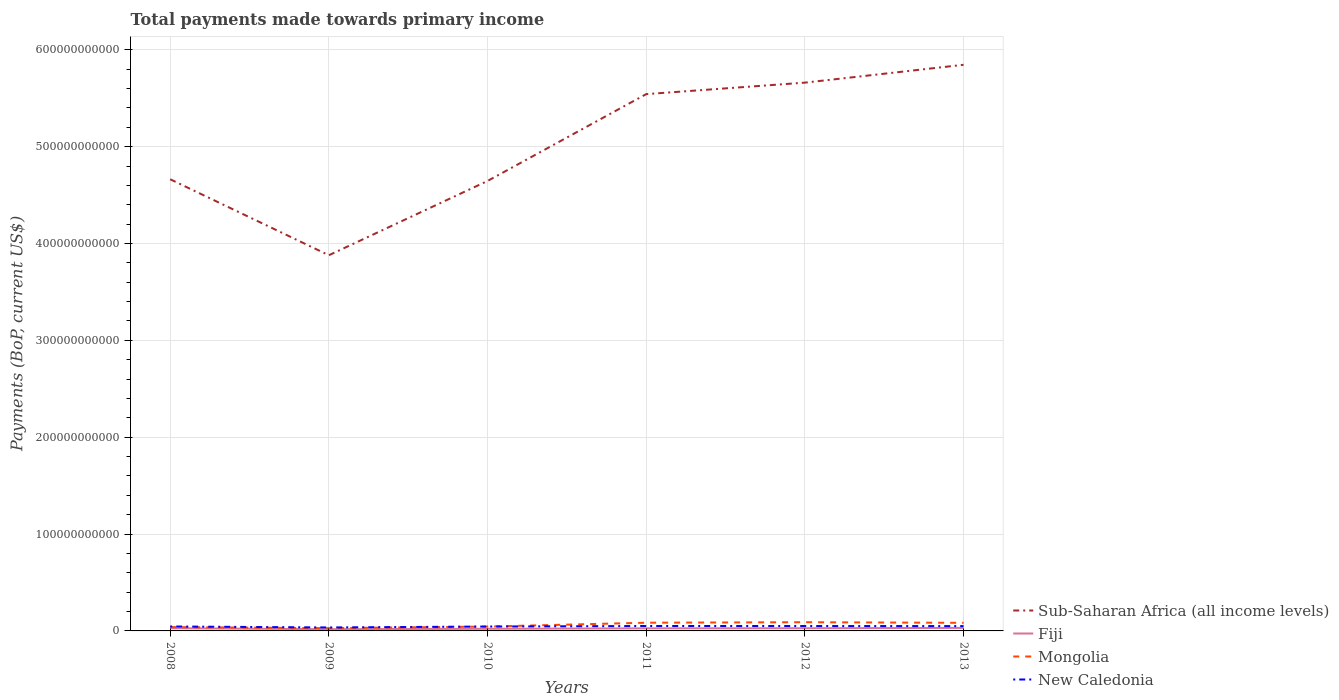How many different coloured lines are there?
Make the answer very short. 4. Does the line corresponding to Sub-Saharan Africa (all income levels) intersect with the line corresponding to Mongolia?
Give a very brief answer. No. Across all years, what is the maximum total payments made towards primary income in Sub-Saharan Africa (all income levels)?
Your response must be concise. 3.88e+11. What is the total total payments made towards primary income in Sub-Saharan Africa (all income levels) in the graph?
Keep it short and to the point. -3.03e+1. What is the difference between the highest and the second highest total payments made towards primary income in New Caledonia?
Offer a terse response. 1.51e+09. Is the total payments made towards primary income in Mongolia strictly greater than the total payments made towards primary income in Fiji over the years?
Your answer should be compact. No. How many years are there in the graph?
Make the answer very short. 6. What is the difference between two consecutive major ticks on the Y-axis?
Offer a terse response. 1.00e+11. Does the graph contain any zero values?
Ensure brevity in your answer.  No. Where does the legend appear in the graph?
Your response must be concise. Bottom right. How many legend labels are there?
Your answer should be very brief. 4. What is the title of the graph?
Your answer should be compact. Total payments made towards primary income. Does "Burundi" appear as one of the legend labels in the graph?
Your response must be concise. No. What is the label or title of the Y-axis?
Your answer should be very brief. Payments (BoP, current US$). What is the Payments (BoP, current US$) in Sub-Saharan Africa (all income levels) in 2008?
Your answer should be very brief. 4.66e+11. What is the Payments (BoP, current US$) in Fiji in 2008?
Make the answer very short. 2.77e+09. What is the Payments (BoP, current US$) in Mongolia in 2008?
Ensure brevity in your answer.  3.96e+09. What is the Payments (BoP, current US$) of New Caledonia in 2008?
Your answer should be very brief. 4.59e+09. What is the Payments (BoP, current US$) in Sub-Saharan Africa (all income levels) in 2009?
Provide a short and direct response. 3.88e+11. What is the Payments (BoP, current US$) of Fiji in 2009?
Ensure brevity in your answer.  1.79e+09. What is the Payments (BoP, current US$) of Mongolia in 2009?
Your response must be concise. 2.85e+09. What is the Payments (BoP, current US$) in New Caledonia in 2009?
Give a very brief answer. 3.58e+09. What is the Payments (BoP, current US$) of Sub-Saharan Africa (all income levels) in 2010?
Give a very brief answer. 4.65e+11. What is the Payments (BoP, current US$) of Fiji in 2010?
Provide a short and direct response. 2.19e+09. What is the Payments (BoP, current US$) of Mongolia in 2010?
Your answer should be very brief. 4.50e+09. What is the Payments (BoP, current US$) in New Caledonia in 2010?
Keep it short and to the point. 4.53e+09. What is the Payments (BoP, current US$) in Sub-Saharan Africa (all income levels) in 2011?
Provide a succinct answer. 5.54e+11. What is the Payments (BoP, current US$) of Fiji in 2011?
Provide a short and direct response. 2.67e+09. What is the Payments (BoP, current US$) of Mongolia in 2011?
Make the answer very short. 8.48e+09. What is the Payments (BoP, current US$) in New Caledonia in 2011?
Give a very brief answer. 5.09e+09. What is the Payments (BoP, current US$) of Sub-Saharan Africa (all income levels) in 2012?
Your answer should be very brief. 5.66e+11. What is the Payments (BoP, current US$) in Fiji in 2012?
Ensure brevity in your answer.  2.78e+09. What is the Payments (BoP, current US$) of Mongolia in 2012?
Offer a terse response. 9.00e+09. What is the Payments (BoP, current US$) of New Caledonia in 2012?
Keep it short and to the point. 5.05e+09. What is the Payments (BoP, current US$) in Sub-Saharan Africa (all income levels) in 2013?
Give a very brief answer. 5.84e+11. What is the Payments (BoP, current US$) in Fiji in 2013?
Ensure brevity in your answer.  3.11e+09. What is the Payments (BoP, current US$) in Mongolia in 2013?
Ensure brevity in your answer.  8.36e+09. What is the Payments (BoP, current US$) in New Caledonia in 2013?
Offer a very short reply. 4.98e+09. Across all years, what is the maximum Payments (BoP, current US$) in Sub-Saharan Africa (all income levels)?
Provide a short and direct response. 5.84e+11. Across all years, what is the maximum Payments (BoP, current US$) of Fiji?
Give a very brief answer. 3.11e+09. Across all years, what is the maximum Payments (BoP, current US$) of Mongolia?
Your answer should be compact. 9.00e+09. Across all years, what is the maximum Payments (BoP, current US$) in New Caledonia?
Keep it short and to the point. 5.09e+09. Across all years, what is the minimum Payments (BoP, current US$) in Sub-Saharan Africa (all income levels)?
Offer a terse response. 3.88e+11. Across all years, what is the minimum Payments (BoP, current US$) of Fiji?
Keep it short and to the point. 1.79e+09. Across all years, what is the minimum Payments (BoP, current US$) of Mongolia?
Offer a terse response. 2.85e+09. Across all years, what is the minimum Payments (BoP, current US$) of New Caledonia?
Give a very brief answer. 3.58e+09. What is the total Payments (BoP, current US$) in Sub-Saharan Africa (all income levels) in the graph?
Your answer should be very brief. 3.02e+12. What is the total Payments (BoP, current US$) of Fiji in the graph?
Your answer should be very brief. 1.53e+1. What is the total Payments (BoP, current US$) of Mongolia in the graph?
Your response must be concise. 3.71e+1. What is the total Payments (BoP, current US$) of New Caledonia in the graph?
Provide a short and direct response. 2.78e+1. What is the difference between the Payments (BoP, current US$) of Sub-Saharan Africa (all income levels) in 2008 and that in 2009?
Make the answer very short. 7.84e+1. What is the difference between the Payments (BoP, current US$) in Fiji in 2008 and that in 2009?
Your response must be concise. 9.83e+08. What is the difference between the Payments (BoP, current US$) of Mongolia in 2008 and that in 2009?
Provide a succinct answer. 1.11e+09. What is the difference between the Payments (BoP, current US$) of New Caledonia in 2008 and that in 2009?
Offer a terse response. 1.02e+09. What is the difference between the Payments (BoP, current US$) in Sub-Saharan Africa (all income levels) in 2008 and that in 2010?
Make the answer very short. 1.75e+09. What is the difference between the Payments (BoP, current US$) in Fiji in 2008 and that in 2010?
Give a very brief answer. 5.79e+08. What is the difference between the Payments (BoP, current US$) of Mongolia in 2008 and that in 2010?
Your response must be concise. -5.40e+08. What is the difference between the Payments (BoP, current US$) in New Caledonia in 2008 and that in 2010?
Make the answer very short. 6.52e+07. What is the difference between the Payments (BoP, current US$) in Sub-Saharan Africa (all income levels) in 2008 and that in 2011?
Your answer should be very brief. -8.79e+1. What is the difference between the Payments (BoP, current US$) of Fiji in 2008 and that in 2011?
Your answer should be compact. 9.97e+07. What is the difference between the Payments (BoP, current US$) of Mongolia in 2008 and that in 2011?
Provide a succinct answer. -4.52e+09. What is the difference between the Payments (BoP, current US$) of New Caledonia in 2008 and that in 2011?
Make the answer very short. -4.95e+08. What is the difference between the Payments (BoP, current US$) of Sub-Saharan Africa (all income levels) in 2008 and that in 2012?
Offer a very short reply. -9.98e+1. What is the difference between the Payments (BoP, current US$) of Fiji in 2008 and that in 2012?
Offer a terse response. -9.86e+06. What is the difference between the Payments (BoP, current US$) of Mongolia in 2008 and that in 2012?
Offer a very short reply. -5.05e+09. What is the difference between the Payments (BoP, current US$) in New Caledonia in 2008 and that in 2012?
Provide a succinct answer. -4.58e+08. What is the difference between the Payments (BoP, current US$) of Sub-Saharan Africa (all income levels) in 2008 and that in 2013?
Provide a succinct answer. -1.18e+11. What is the difference between the Payments (BoP, current US$) of Fiji in 2008 and that in 2013?
Keep it short and to the point. -3.41e+08. What is the difference between the Payments (BoP, current US$) in Mongolia in 2008 and that in 2013?
Your response must be concise. -4.41e+09. What is the difference between the Payments (BoP, current US$) in New Caledonia in 2008 and that in 2013?
Ensure brevity in your answer.  -3.91e+08. What is the difference between the Payments (BoP, current US$) of Sub-Saharan Africa (all income levels) in 2009 and that in 2010?
Give a very brief answer. -7.67e+1. What is the difference between the Payments (BoP, current US$) of Fiji in 2009 and that in 2010?
Provide a short and direct response. -4.04e+08. What is the difference between the Payments (BoP, current US$) in Mongolia in 2009 and that in 2010?
Make the answer very short. -1.65e+09. What is the difference between the Payments (BoP, current US$) in New Caledonia in 2009 and that in 2010?
Keep it short and to the point. -9.52e+08. What is the difference between the Payments (BoP, current US$) of Sub-Saharan Africa (all income levels) in 2009 and that in 2011?
Provide a short and direct response. -1.66e+11. What is the difference between the Payments (BoP, current US$) of Fiji in 2009 and that in 2011?
Provide a succinct answer. -8.83e+08. What is the difference between the Payments (BoP, current US$) of Mongolia in 2009 and that in 2011?
Your answer should be compact. -5.63e+09. What is the difference between the Payments (BoP, current US$) in New Caledonia in 2009 and that in 2011?
Keep it short and to the point. -1.51e+09. What is the difference between the Payments (BoP, current US$) in Sub-Saharan Africa (all income levels) in 2009 and that in 2012?
Make the answer very short. -1.78e+11. What is the difference between the Payments (BoP, current US$) of Fiji in 2009 and that in 2012?
Make the answer very short. -9.93e+08. What is the difference between the Payments (BoP, current US$) of Mongolia in 2009 and that in 2012?
Provide a short and direct response. -6.15e+09. What is the difference between the Payments (BoP, current US$) of New Caledonia in 2009 and that in 2012?
Make the answer very short. -1.48e+09. What is the difference between the Payments (BoP, current US$) of Sub-Saharan Africa (all income levels) in 2009 and that in 2013?
Provide a short and direct response. -1.97e+11. What is the difference between the Payments (BoP, current US$) in Fiji in 2009 and that in 2013?
Your response must be concise. -1.32e+09. What is the difference between the Payments (BoP, current US$) in Mongolia in 2009 and that in 2013?
Your answer should be compact. -5.51e+09. What is the difference between the Payments (BoP, current US$) of New Caledonia in 2009 and that in 2013?
Your response must be concise. -1.41e+09. What is the difference between the Payments (BoP, current US$) in Sub-Saharan Africa (all income levels) in 2010 and that in 2011?
Provide a short and direct response. -8.97e+1. What is the difference between the Payments (BoP, current US$) of Fiji in 2010 and that in 2011?
Give a very brief answer. -4.79e+08. What is the difference between the Payments (BoP, current US$) of Mongolia in 2010 and that in 2011?
Provide a succinct answer. -3.98e+09. What is the difference between the Payments (BoP, current US$) of New Caledonia in 2010 and that in 2011?
Give a very brief answer. -5.60e+08. What is the difference between the Payments (BoP, current US$) in Sub-Saharan Africa (all income levels) in 2010 and that in 2012?
Your answer should be compact. -1.02e+11. What is the difference between the Payments (BoP, current US$) of Fiji in 2010 and that in 2012?
Your answer should be very brief. -5.89e+08. What is the difference between the Payments (BoP, current US$) of Mongolia in 2010 and that in 2012?
Make the answer very short. -4.51e+09. What is the difference between the Payments (BoP, current US$) in New Caledonia in 2010 and that in 2012?
Your response must be concise. -5.23e+08. What is the difference between the Payments (BoP, current US$) of Sub-Saharan Africa (all income levels) in 2010 and that in 2013?
Provide a succinct answer. -1.20e+11. What is the difference between the Payments (BoP, current US$) in Fiji in 2010 and that in 2013?
Your response must be concise. -9.20e+08. What is the difference between the Payments (BoP, current US$) in Mongolia in 2010 and that in 2013?
Give a very brief answer. -3.87e+09. What is the difference between the Payments (BoP, current US$) in New Caledonia in 2010 and that in 2013?
Your response must be concise. -4.56e+08. What is the difference between the Payments (BoP, current US$) of Sub-Saharan Africa (all income levels) in 2011 and that in 2012?
Offer a very short reply. -1.19e+1. What is the difference between the Payments (BoP, current US$) of Fiji in 2011 and that in 2012?
Provide a short and direct response. -1.10e+08. What is the difference between the Payments (BoP, current US$) of Mongolia in 2011 and that in 2012?
Your answer should be compact. -5.24e+08. What is the difference between the Payments (BoP, current US$) in New Caledonia in 2011 and that in 2012?
Make the answer very short. 3.68e+07. What is the difference between the Payments (BoP, current US$) in Sub-Saharan Africa (all income levels) in 2011 and that in 2013?
Ensure brevity in your answer.  -3.03e+1. What is the difference between the Payments (BoP, current US$) of Fiji in 2011 and that in 2013?
Offer a terse response. -4.41e+08. What is the difference between the Payments (BoP, current US$) of Mongolia in 2011 and that in 2013?
Provide a succinct answer. 1.16e+08. What is the difference between the Payments (BoP, current US$) of New Caledonia in 2011 and that in 2013?
Ensure brevity in your answer.  1.04e+08. What is the difference between the Payments (BoP, current US$) of Sub-Saharan Africa (all income levels) in 2012 and that in 2013?
Ensure brevity in your answer.  -1.84e+1. What is the difference between the Payments (BoP, current US$) in Fiji in 2012 and that in 2013?
Provide a succinct answer. -3.31e+08. What is the difference between the Payments (BoP, current US$) in Mongolia in 2012 and that in 2013?
Give a very brief answer. 6.40e+08. What is the difference between the Payments (BoP, current US$) of New Caledonia in 2012 and that in 2013?
Provide a short and direct response. 6.75e+07. What is the difference between the Payments (BoP, current US$) of Sub-Saharan Africa (all income levels) in 2008 and the Payments (BoP, current US$) of Fiji in 2009?
Make the answer very short. 4.65e+11. What is the difference between the Payments (BoP, current US$) in Sub-Saharan Africa (all income levels) in 2008 and the Payments (BoP, current US$) in Mongolia in 2009?
Offer a very short reply. 4.63e+11. What is the difference between the Payments (BoP, current US$) of Sub-Saharan Africa (all income levels) in 2008 and the Payments (BoP, current US$) of New Caledonia in 2009?
Your response must be concise. 4.63e+11. What is the difference between the Payments (BoP, current US$) in Fiji in 2008 and the Payments (BoP, current US$) in Mongolia in 2009?
Ensure brevity in your answer.  -8.18e+07. What is the difference between the Payments (BoP, current US$) in Fiji in 2008 and the Payments (BoP, current US$) in New Caledonia in 2009?
Keep it short and to the point. -8.07e+08. What is the difference between the Payments (BoP, current US$) of Mongolia in 2008 and the Payments (BoP, current US$) of New Caledonia in 2009?
Offer a terse response. 3.81e+08. What is the difference between the Payments (BoP, current US$) in Sub-Saharan Africa (all income levels) in 2008 and the Payments (BoP, current US$) in Fiji in 2010?
Offer a terse response. 4.64e+11. What is the difference between the Payments (BoP, current US$) in Sub-Saharan Africa (all income levels) in 2008 and the Payments (BoP, current US$) in Mongolia in 2010?
Your answer should be compact. 4.62e+11. What is the difference between the Payments (BoP, current US$) in Sub-Saharan Africa (all income levels) in 2008 and the Payments (BoP, current US$) in New Caledonia in 2010?
Your answer should be very brief. 4.62e+11. What is the difference between the Payments (BoP, current US$) in Fiji in 2008 and the Payments (BoP, current US$) in Mongolia in 2010?
Offer a very short reply. -1.73e+09. What is the difference between the Payments (BoP, current US$) in Fiji in 2008 and the Payments (BoP, current US$) in New Caledonia in 2010?
Ensure brevity in your answer.  -1.76e+09. What is the difference between the Payments (BoP, current US$) in Mongolia in 2008 and the Payments (BoP, current US$) in New Caledonia in 2010?
Ensure brevity in your answer.  -5.72e+08. What is the difference between the Payments (BoP, current US$) of Sub-Saharan Africa (all income levels) in 2008 and the Payments (BoP, current US$) of Fiji in 2011?
Your answer should be very brief. 4.64e+11. What is the difference between the Payments (BoP, current US$) in Sub-Saharan Africa (all income levels) in 2008 and the Payments (BoP, current US$) in Mongolia in 2011?
Give a very brief answer. 4.58e+11. What is the difference between the Payments (BoP, current US$) in Sub-Saharan Africa (all income levels) in 2008 and the Payments (BoP, current US$) in New Caledonia in 2011?
Provide a succinct answer. 4.61e+11. What is the difference between the Payments (BoP, current US$) in Fiji in 2008 and the Payments (BoP, current US$) in Mongolia in 2011?
Make the answer very short. -5.71e+09. What is the difference between the Payments (BoP, current US$) of Fiji in 2008 and the Payments (BoP, current US$) of New Caledonia in 2011?
Keep it short and to the point. -2.32e+09. What is the difference between the Payments (BoP, current US$) of Mongolia in 2008 and the Payments (BoP, current US$) of New Caledonia in 2011?
Ensure brevity in your answer.  -1.13e+09. What is the difference between the Payments (BoP, current US$) in Sub-Saharan Africa (all income levels) in 2008 and the Payments (BoP, current US$) in Fiji in 2012?
Your response must be concise. 4.64e+11. What is the difference between the Payments (BoP, current US$) of Sub-Saharan Africa (all income levels) in 2008 and the Payments (BoP, current US$) of Mongolia in 2012?
Offer a terse response. 4.57e+11. What is the difference between the Payments (BoP, current US$) in Sub-Saharan Africa (all income levels) in 2008 and the Payments (BoP, current US$) in New Caledonia in 2012?
Give a very brief answer. 4.61e+11. What is the difference between the Payments (BoP, current US$) of Fiji in 2008 and the Payments (BoP, current US$) of Mongolia in 2012?
Provide a succinct answer. -6.24e+09. What is the difference between the Payments (BoP, current US$) of Fiji in 2008 and the Payments (BoP, current US$) of New Caledonia in 2012?
Make the answer very short. -2.28e+09. What is the difference between the Payments (BoP, current US$) in Mongolia in 2008 and the Payments (BoP, current US$) in New Caledonia in 2012?
Your response must be concise. -1.10e+09. What is the difference between the Payments (BoP, current US$) in Sub-Saharan Africa (all income levels) in 2008 and the Payments (BoP, current US$) in Fiji in 2013?
Give a very brief answer. 4.63e+11. What is the difference between the Payments (BoP, current US$) in Sub-Saharan Africa (all income levels) in 2008 and the Payments (BoP, current US$) in Mongolia in 2013?
Keep it short and to the point. 4.58e+11. What is the difference between the Payments (BoP, current US$) in Sub-Saharan Africa (all income levels) in 2008 and the Payments (BoP, current US$) in New Caledonia in 2013?
Offer a very short reply. 4.61e+11. What is the difference between the Payments (BoP, current US$) of Fiji in 2008 and the Payments (BoP, current US$) of Mongolia in 2013?
Offer a very short reply. -5.60e+09. What is the difference between the Payments (BoP, current US$) of Fiji in 2008 and the Payments (BoP, current US$) of New Caledonia in 2013?
Give a very brief answer. -2.22e+09. What is the difference between the Payments (BoP, current US$) in Mongolia in 2008 and the Payments (BoP, current US$) in New Caledonia in 2013?
Offer a very short reply. -1.03e+09. What is the difference between the Payments (BoP, current US$) of Sub-Saharan Africa (all income levels) in 2009 and the Payments (BoP, current US$) of Fiji in 2010?
Your response must be concise. 3.86e+11. What is the difference between the Payments (BoP, current US$) in Sub-Saharan Africa (all income levels) in 2009 and the Payments (BoP, current US$) in Mongolia in 2010?
Make the answer very short. 3.83e+11. What is the difference between the Payments (BoP, current US$) of Sub-Saharan Africa (all income levels) in 2009 and the Payments (BoP, current US$) of New Caledonia in 2010?
Make the answer very short. 3.83e+11. What is the difference between the Payments (BoP, current US$) of Fiji in 2009 and the Payments (BoP, current US$) of Mongolia in 2010?
Keep it short and to the point. -2.71e+09. What is the difference between the Payments (BoP, current US$) of Fiji in 2009 and the Payments (BoP, current US$) of New Caledonia in 2010?
Provide a succinct answer. -2.74e+09. What is the difference between the Payments (BoP, current US$) in Mongolia in 2009 and the Payments (BoP, current US$) in New Caledonia in 2010?
Your answer should be compact. -1.68e+09. What is the difference between the Payments (BoP, current US$) in Sub-Saharan Africa (all income levels) in 2009 and the Payments (BoP, current US$) in Fiji in 2011?
Make the answer very short. 3.85e+11. What is the difference between the Payments (BoP, current US$) in Sub-Saharan Africa (all income levels) in 2009 and the Payments (BoP, current US$) in Mongolia in 2011?
Your response must be concise. 3.79e+11. What is the difference between the Payments (BoP, current US$) of Sub-Saharan Africa (all income levels) in 2009 and the Payments (BoP, current US$) of New Caledonia in 2011?
Give a very brief answer. 3.83e+11. What is the difference between the Payments (BoP, current US$) in Fiji in 2009 and the Payments (BoP, current US$) in Mongolia in 2011?
Ensure brevity in your answer.  -6.69e+09. What is the difference between the Payments (BoP, current US$) in Fiji in 2009 and the Payments (BoP, current US$) in New Caledonia in 2011?
Keep it short and to the point. -3.30e+09. What is the difference between the Payments (BoP, current US$) of Mongolia in 2009 and the Payments (BoP, current US$) of New Caledonia in 2011?
Ensure brevity in your answer.  -2.24e+09. What is the difference between the Payments (BoP, current US$) of Sub-Saharan Africa (all income levels) in 2009 and the Payments (BoP, current US$) of Fiji in 2012?
Keep it short and to the point. 3.85e+11. What is the difference between the Payments (BoP, current US$) of Sub-Saharan Africa (all income levels) in 2009 and the Payments (BoP, current US$) of Mongolia in 2012?
Keep it short and to the point. 3.79e+11. What is the difference between the Payments (BoP, current US$) in Sub-Saharan Africa (all income levels) in 2009 and the Payments (BoP, current US$) in New Caledonia in 2012?
Provide a succinct answer. 3.83e+11. What is the difference between the Payments (BoP, current US$) of Fiji in 2009 and the Payments (BoP, current US$) of Mongolia in 2012?
Your answer should be very brief. -7.22e+09. What is the difference between the Payments (BoP, current US$) in Fiji in 2009 and the Payments (BoP, current US$) in New Caledonia in 2012?
Your response must be concise. -3.27e+09. What is the difference between the Payments (BoP, current US$) of Mongolia in 2009 and the Payments (BoP, current US$) of New Caledonia in 2012?
Your response must be concise. -2.20e+09. What is the difference between the Payments (BoP, current US$) of Sub-Saharan Africa (all income levels) in 2009 and the Payments (BoP, current US$) of Fiji in 2013?
Ensure brevity in your answer.  3.85e+11. What is the difference between the Payments (BoP, current US$) in Sub-Saharan Africa (all income levels) in 2009 and the Payments (BoP, current US$) in Mongolia in 2013?
Provide a short and direct response. 3.80e+11. What is the difference between the Payments (BoP, current US$) in Sub-Saharan Africa (all income levels) in 2009 and the Payments (BoP, current US$) in New Caledonia in 2013?
Provide a succinct answer. 3.83e+11. What is the difference between the Payments (BoP, current US$) in Fiji in 2009 and the Payments (BoP, current US$) in Mongolia in 2013?
Offer a very short reply. -6.58e+09. What is the difference between the Payments (BoP, current US$) in Fiji in 2009 and the Payments (BoP, current US$) in New Caledonia in 2013?
Provide a short and direct response. -3.20e+09. What is the difference between the Payments (BoP, current US$) of Mongolia in 2009 and the Payments (BoP, current US$) of New Caledonia in 2013?
Ensure brevity in your answer.  -2.13e+09. What is the difference between the Payments (BoP, current US$) of Sub-Saharan Africa (all income levels) in 2010 and the Payments (BoP, current US$) of Fiji in 2011?
Provide a short and direct response. 4.62e+11. What is the difference between the Payments (BoP, current US$) of Sub-Saharan Africa (all income levels) in 2010 and the Payments (BoP, current US$) of Mongolia in 2011?
Offer a terse response. 4.56e+11. What is the difference between the Payments (BoP, current US$) in Sub-Saharan Africa (all income levels) in 2010 and the Payments (BoP, current US$) in New Caledonia in 2011?
Keep it short and to the point. 4.59e+11. What is the difference between the Payments (BoP, current US$) of Fiji in 2010 and the Payments (BoP, current US$) of Mongolia in 2011?
Offer a very short reply. -6.29e+09. What is the difference between the Payments (BoP, current US$) in Fiji in 2010 and the Payments (BoP, current US$) in New Caledonia in 2011?
Provide a short and direct response. -2.90e+09. What is the difference between the Payments (BoP, current US$) in Mongolia in 2010 and the Payments (BoP, current US$) in New Caledonia in 2011?
Provide a short and direct response. -5.92e+08. What is the difference between the Payments (BoP, current US$) in Sub-Saharan Africa (all income levels) in 2010 and the Payments (BoP, current US$) in Fiji in 2012?
Give a very brief answer. 4.62e+11. What is the difference between the Payments (BoP, current US$) of Sub-Saharan Africa (all income levels) in 2010 and the Payments (BoP, current US$) of Mongolia in 2012?
Keep it short and to the point. 4.56e+11. What is the difference between the Payments (BoP, current US$) in Sub-Saharan Africa (all income levels) in 2010 and the Payments (BoP, current US$) in New Caledonia in 2012?
Give a very brief answer. 4.59e+11. What is the difference between the Payments (BoP, current US$) in Fiji in 2010 and the Payments (BoP, current US$) in Mongolia in 2012?
Make the answer very short. -6.81e+09. What is the difference between the Payments (BoP, current US$) in Fiji in 2010 and the Payments (BoP, current US$) in New Caledonia in 2012?
Keep it short and to the point. -2.86e+09. What is the difference between the Payments (BoP, current US$) in Mongolia in 2010 and the Payments (BoP, current US$) in New Caledonia in 2012?
Make the answer very short. -5.55e+08. What is the difference between the Payments (BoP, current US$) in Sub-Saharan Africa (all income levels) in 2010 and the Payments (BoP, current US$) in Fiji in 2013?
Offer a very short reply. 4.61e+11. What is the difference between the Payments (BoP, current US$) of Sub-Saharan Africa (all income levels) in 2010 and the Payments (BoP, current US$) of Mongolia in 2013?
Your answer should be compact. 4.56e+11. What is the difference between the Payments (BoP, current US$) in Sub-Saharan Africa (all income levels) in 2010 and the Payments (BoP, current US$) in New Caledonia in 2013?
Provide a succinct answer. 4.60e+11. What is the difference between the Payments (BoP, current US$) in Fiji in 2010 and the Payments (BoP, current US$) in Mongolia in 2013?
Offer a very short reply. -6.17e+09. What is the difference between the Payments (BoP, current US$) in Fiji in 2010 and the Payments (BoP, current US$) in New Caledonia in 2013?
Offer a terse response. -2.79e+09. What is the difference between the Payments (BoP, current US$) of Mongolia in 2010 and the Payments (BoP, current US$) of New Caledonia in 2013?
Your response must be concise. -4.88e+08. What is the difference between the Payments (BoP, current US$) in Sub-Saharan Africa (all income levels) in 2011 and the Payments (BoP, current US$) in Fiji in 2012?
Your answer should be compact. 5.51e+11. What is the difference between the Payments (BoP, current US$) of Sub-Saharan Africa (all income levels) in 2011 and the Payments (BoP, current US$) of Mongolia in 2012?
Offer a very short reply. 5.45e+11. What is the difference between the Payments (BoP, current US$) in Sub-Saharan Africa (all income levels) in 2011 and the Payments (BoP, current US$) in New Caledonia in 2012?
Your answer should be very brief. 5.49e+11. What is the difference between the Payments (BoP, current US$) in Fiji in 2011 and the Payments (BoP, current US$) in Mongolia in 2012?
Make the answer very short. -6.34e+09. What is the difference between the Payments (BoP, current US$) of Fiji in 2011 and the Payments (BoP, current US$) of New Caledonia in 2012?
Offer a terse response. -2.38e+09. What is the difference between the Payments (BoP, current US$) of Mongolia in 2011 and the Payments (BoP, current US$) of New Caledonia in 2012?
Provide a short and direct response. 3.43e+09. What is the difference between the Payments (BoP, current US$) of Sub-Saharan Africa (all income levels) in 2011 and the Payments (BoP, current US$) of Fiji in 2013?
Offer a very short reply. 5.51e+11. What is the difference between the Payments (BoP, current US$) in Sub-Saharan Africa (all income levels) in 2011 and the Payments (BoP, current US$) in Mongolia in 2013?
Provide a succinct answer. 5.46e+11. What is the difference between the Payments (BoP, current US$) in Sub-Saharan Africa (all income levels) in 2011 and the Payments (BoP, current US$) in New Caledonia in 2013?
Provide a short and direct response. 5.49e+11. What is the difference between the Payments (BoP, current US$) in Fiji in 2011 and the Payments (BoP, current US$) in Mongolia in 2013?
Make the answer very short. -5.70e+09. What is the difference between the Payments (BoP, current US$) in Fiji in 2011 and the Payments (BoP, current US$) in New Caledonia in 2013?
Provide a succinct answer. -2.32e+09. What is the difference between the Payments (BoP, current US$) in Mongolia in 2011 and the Payments (BoP, current US$) in New Caledonia in 2013?
Your answer should be very brief. 3.50e+09. What is the difference between the Payments (BoP, current US$) in Sub-Saharan Africa (all income levels) in 2012 and the Payments (BoP, current US$) in Fiji in 2013?
Provide a short and direct response. 5.63e+11. What is the difference between the Payments (BoP, current US$) of Sub-Saharan Africa (all income levels) in 2012 and the Payments (BoP, current US$) of Mongolia in 2013?
Provide a succinct answer. 5.58e+11. What is the difference between the Payments (BoP, current US$) in Sub-Saharan Africa (all income levels) in 2012 and the Payments (BoP, current US$) in New Caledonia in 2013?
Offer a terse response. 5.61e+11. What is the difference between the Payments (BoP, current US$) of Fiji in 2012 and the Payments (BoP, current US$) of Mongolia in 2013?
Provide a succinct answer. -5.59e+09. What is the difference between the Payments (BoP, current US$) of Fiji in 2012 and the Payments (BoP, current US$) of New Caledonia in 2013?
Keep it short and to the point. -2.21e+09. What is the difference between the Payments (BoP, current US$) in Mongolia in 2012 and the Payments (BoP, current US$) in New Caledonia in 2013?
Offer a terse response. 4.02e+09. What is the average Payments (BoP, current US$) of Sub-Saharan Africa (all income levels) per year?
Your response must be concise. 5.04e+11. What is the average Payments (BoP, current US$) in Fiji per year?
Your answer should be very brief. 2.55e+09. What is the average Payments (BoP, current US$) in Mongolia per year?
Give a very brief answer. 6.19e+09. What is the average Payments (BoP, current US$) in New Caledonia per year?
Offer a terse response. 4.64e+09. In the year 2008, what is the difference between the Payments (BoP, current US$) in Sub-Saharan Africa (all income levels) and Payments (BoP, current US$) in Fiji?
Give a very brief answer. 4.64e+11. In the year 2008, what is the difference between the Payments (BoP, current US$) in Sub-Saharan Africa (all income levels) and Payments (BoP, current US$) in Mongolia?
Ensure brevity in your answer.  4.62e+11. In the year 2008, what is the difference between the Payments (BoP, current US$) in Sub-Saharan Africa (all income levels) and Payments (BoP, current US$) in New Caledonia?
Offer a terse response. 4.62e+11. In the year 2008, what is the difference between the Payments (BoP, current US$) of Fiji and Payments (BoP, current US$) of Mongolia?
Keep it short and to the point. -1.19e+09. In the year 2008, what is the difference between the Payments (BoP, current US$) of Fiji and Payments (BoP, current US$) of New Caledonia?
Your answer should be compact. -1.82e+09. In the year 2008, what is the difference between the Payments (BoP, current US$) in Mongolia and Payments (BoP, current US$) in New Caledonia?
Your response must be concise. -6.37e+08. In the year 2009, what is the difference between the Payments (BoP, current US$) of Sub-Saharan Africa (all income levels) and Payments (BoP, current US$) of Fiji?
Offer a very short reply. 3.86e+11. In the year 2009, what is the difference between the Payments (BoP, current US$) of Sub-Saharan Africa (all income levels) and Payments (BoP, current US$) of Mongolia?
Offer a terse response. 3.85e+11. In the year 2009, what is the difference between the Payments (BoP, current US$) of Sub-Saharan Africa (all income levels) and Payments (BoP, current US$) of New Caledonia?
Provide a succinct answer. 3.84e+11. In the year 2009, what is the difference between the Payments (BoP, current US$) of Fiji and Payments (BoP, current US$) of Mongolia?
Make the answer very short. -1.06e+09. In the year 2009, what is the difference between the Payments (BoP, current US$) of Fiji and Payments (BoP, current US$) of New Caledonia?
Provide a short and direct response. -1.79e+09. In the year 2009, what is the difference between the Payments (BoP, current US$) of Mongolia and Payments (BoP, current US$) of New Caledonia?
Offer a very short reply. -7.25e+08. In the year 2010, what is the difference between the Payments (BoP, current US$) of Sub-Saharan Africa (all income levels) and Payments (BoP, current US$) of Fiji?
Offer a terse response. 4.62e+11. In the year 2010, what is the difference between the Payments (BoP, current US$) of Sub-Saharan Africa (all income levels) and Payments (BoP, current US$) of Mongolia?
Provide a short and direct response. 4.60e+11. In the year 2010, what is the difference between the Payments (BoP, current US$) in Sub-Saharan Africa (all income levels) and Payments (BoP, current US$) in New Caledonia?
Your answer should be very brief. 4.60e+11. In the year 2010, what is the difference between the Payments (BoP, current US$) in Fiji and Payments (BoP, current US$) in Mongolia?
Your response must be concise. -2.31e+09. In the year 2010, what is the difference between the Payments (BoP, current US$) of Fiji and Payments (BoP, current US$) of New Caledonia?
Offer a terse response. -2.34e+09. In the year 2010, what is the difference between the Payments (BoP, current US$) of Mongolia and Payments (BoP, current US$) of New Caledonia?
Your response must be concise. -3.20e+07. In the year 2011, what is the difference between the Payments (BoP, current US$) of Sub-Saharan Africa (all income levels) and Payments (BoP, current US$) of Fiji?
Provide a succinct answer. 5.52e+11. In the year 2011, what is the difference between the Payments (BoP, current US$) in Sub-Saharan Africa (all income levels) and Payments (BoP, current US$) in Mongolia?
Offer a very short reply. 5.46e+11. In the year 2011, what is the difference between the Payments (BoP, current US$) in Sub-Saharan Africa (all income levels) and Payments (BoP, current US$) in New Caledonia?
Provide a short and direct response. 5.49e+11. In the year 2011, what is the difference between the Payments (BoP, current US$) in Fiji and Payments (BoP, current US$) in Mongolia?
Your answer should be very brief. -5.81e+09. In the year 2011, what is the difference between the Payments (BoP, current US$) in Fiji and Payments (BoP, current US$) in New Caledonia?
Make the answer very short. -2.42e+09. In the year 2011, what is the difference between the Payments (BoP, current US$) of Mongolia and Payments (BoP, current US$) of New Caledonia?
Offer a terse response. 3.39e+09. In the year 2012, what is the difference between the Payments (BoP, current US$) in Sub-Saharan Africa (all income levels) and Payments (BoP, current US$) in Fiji?
Keep it short and to the point. 5.63e+11. In the year 2012, what is the difference between the Payments (BoP, current US$) of Sub-Saharan Africa (all income levels) and Payments (BoP, current US$) of Mongolia?
Keep it short and to the point. 5.57e+11. In the year 2012, what is the difference between the Payments (BoP, current US$) in Sub-Saharan Africa (all income levels) and Payments (BoP, current US$) in New Caledonia?
Ensure brevity in your answer.  5.61e+11. In the year 2012, what is the difference between the Payments (BoP, current US$) in Fiji and Payments (BoP, current US$) in Mongolia?
Your answer should be very brief. -6.23e+09. In the year 2012, what is the difference between the Payments (BoP, current US$) of Fiji and Payments (BoP, current US$) of New Caledonia?
Offer a terse response. -2.27e+09. In the year 2012, what is the difference between the Payments (BoP, current US$) in Mongolia and Payments (BoP, current US$) in New Caledonia?
Keep it short and to the point. 3.95e+09. In the year 2013, what is the difference between the Payments (BoP, current US$) of Sub-Saharan Africa (all income levels) and Payments (BoP, current US$) of Fiji?
Your answer should be compact. 5.81e+11. In the year 2013, what is the difference between the Payments (BoP, current US$) of Sub-Saharan Africa (all income levels) and Payments (BoP, current US$) of Mongolia?
Provide a succinct answer. 5.76e+11. In the year 2013, what is the difference between the Payments (BoP, current US$) of Sub-Saharan Africa (all income levels) and Payments (BoP, current US$) of New Caledonia?
Make the answer very short. 5.80e+11. In the year 2013, what is the difference between the Payments (BoP, current US$) in Fiji and Payments (BoP, current US$) in Mongolia?
Your response must be concise. -5.25e+09. In the year 2013, what is the difference between the Payments (BoP, current US$) in Fiji and Payments (BoP, current US$) in New Caledonia?
Your response must be concise. -1.87e+09. In the year 2013, what is the difference between the Payments (BoP, current US$) of Mongolia and Payments (BoP, current US$) of New Caledonia?
Offer a terse response. 3.38e+09. What is the ratio of the Payments (BoP, current US$) of Sub-Saharan Africa (all income levels) in 2008 to that in 2009?
Your answer should be compact. 1.2. What is the ratio of the Payments (BoP, current US$) in Fiji in 2008 to that in 2009?
Offer a very short reply. 1.55. What is the ratio of the Payments (BoP, current US$) in Mongolia in 2008 to that in 2009?
Provide a succinct answer. 1.39. What is the ratio of the Payments (BoP, current US$) of New Caledonia in 2008 to that in 2009?
Keep it short and to the point. 1.28. What is the ratio of the Payments (BoP, current US$) of Sub-Saharan Africa (all income levels) in 2008 to that in 2010?
Your answer should be very brief. 1. What is the ratio of the Payments (BoP, current US$) of Fiji in 2008 to that in 2010?
Offer a very short reply. 1.26. What is the ratio of the Payments (BoP, current US$) in Mongolia in 2008 to that in 2010?
Offer a very short reply. 0.88. What is the ratio of the Payments (BoP, current US$) of New Caledonia in 2008 to that in 2010?
Keep it short and to the point. 1.01. What is the ratio of the Payments (BoP, current US$) of Sub-Saharan Africa (all income levels) in 2008 to that in 2011?
Provide a succinct answer. 0.84. What is the ratio of the Payments (BoP, current US$) in Fiji in 2008 to that in 2011?
Provide a succinct answer. 1.04. What is the ratio of the Payments (BoP, current US$) of Mongolia in 2008 to that in 2011?
Offer a terse response. 0.47. What is the ratio of the Payments (BoP, current US$) of New Caledonia in 2008 to that in 2011?
Your answer should be compact. 0.9. What is the ratio of the Payments (BoP, current US$) in Sub-Saharan Africa (all income levels) in 2008 to that in 2012?
Keep it short and to the point. 0.82. What is the ratio of the Payments (BoP, current US$) in Fiji in 2008 to that in 2012?
Your answer should be compact. 1. What is the ratio of the Payments (BoP, current US$) in Mongolia in 2008 to that in 2012?
Your answer should be compact. 0.44. What is the ratio of the Payments (BoP, current US$) of New Caledonia in 2008 to that in 2012?
Offer a terse response. 0.91. What is the ratio of the Payments (BoP, current US$) of Sub-Saharan Africa (all income levels) in 2008 to that in 2013?
Provide a succinct answer. 0.8. What is the ratio of the Payments (BoP, current US$) in Fiji in 2008 to that in 2013?
Keep it short and to the point. 0.89. What is the ratio of the Payments (BoP, current US$) in Mongolia in 2008 to that in 2013?
Your answer should be very brief. 0.47. What is the ratio of the Payments (BoP, current US$) in New Caledonia in 2008 to that in 2013?
Offer a terse response. 0.92. What is the ratio of the Payments (BoP, current US$) of Sub-Saharan Africa (all income levels) in 2009 to that in 2010?
Provide a succinct answer. 0.83. What is the ratio of the Payments (BoP, current US$) in Fiji in 2009 to that in 2010?
Your answer should be very brief. 0.82. What is the ratio of the Payments (BoP, current US$) of Mongolia in 2009 to that in 2010?
Your response must be concise. 0.63. What is the ratio of the Payments (BoP, current US$) of New Caledonia in 2009 to that in 2010?
Ensure brevity in your answer.  0.79. What is the ratio of the Payments (BoP, current US$) of Sub-Saharan Africa (all income levels) in 2009 to that in 2011?
Your answer should be very brief. 0.7. What is the ratio of the Payments (BoP, current US$) in Fiji in 2009 to that in 2011?
Your answer should be very brief. 0.67. What is the ratio of the Payments (BoP, current US$) in Mongolia in 2009 to that in 2011?
Make the answer very short. 0.34. What is the ratio of the Payments (BoP, current US$) in New Caledonia in 2009 to that in 2011?
Offer a terse response. 0.7. What is the ratio of the Payments (BoP, current US$) in Sub-Saharan Africa (all income levels) in 2009 to that in 2012?
Your answer should be compact. 0.69. What is the ratio of the Payments (BoP, current US$) of Fiji in 2009 to that in 2012?
Keep it short and to the point. 0.64. What is the ratio of the Payments (BoP, current US$) of Mongolia in 2009 to that in 2012?
Ensure brevity in your answer.  0.32. What is the ratio of the Payments (BoP, current US$) in New Caledonia in 2009 to that in 2012?
Offer a terse response. 0.71. What is the ratio of the Payments (BoP, current US$) in Sub-Saharan Africa (all income levels) in 2009 to that in 2013?
Your answer should be compact. 0.66. What is the ratio of the Payments (BoP, current US$) of Fiji in 2009 to that in 2013?
Your answer should be compact. 0.57. What is the ratio of the Payments (BoP, current US$) of Mongolia in 2009 to that in 2013?
Your answer should be compact. 0.34. What is the ratio of the Payments (BoP, current US$) of New Caledonia in 2009 to that in 2013?
Your answer should be very brief. 0.72. What is the ratio of the Payments (BoP, current US$) of Sub-Saharan Africa (all income levels) in 2010 to that in 2011?
Ensure brevity in your answer.  0.84. What is the ratio of the Payments (BoP, current US$) in Fiji in 2010 to that in 2011?
Your answer should be very brief. 0.82. What is the ratio of the Payments (BoP, current US$) in Mongolia in 2010 to that in 2011?
Keep it short and to the point. 0.53. What is the ratio of the Payments (BoP, current US$) in New Caledonia in 2010 to that in 2011?
Provide a succinct answer. 0.89. What is the ratio of the Payments (BoP, current US$) of Sub-Saharan Africa (all income levels) in 2010 to that in 2012?
Ensure brevity in your answer.  0.82. What is the ratio of the Payments (BoP, current US$) of Fiji in 2010 to that in 2012?
Provide a short and direct response. 0.79. What is the ratio of the Payments (BoP, current US$) in Mongolia in 2010 to that in 2012?
Make the answer very short. 0.5. What is the ratio of the Payments (BoP, current US$) of New Caledonia in 2010 to that in 2012?
Make the answer very short. 0.9. What is the ratio of the Payments (BoP, current US$) in Sub-Saharan Africa (all income levels) in 2010 to that in 2013?
Your answer should be compact. 0.79. What is the ratio of the Payments (BoP, current US$) of Fiji in 2010 to that in 2013?
Keep it short and to the point. 0.7. What is the ratio of the Payments (BoP, current US$) of Mongolia in 2010 to that in 2013?
Offer a very short reply. 0.54. What is the ratio of the Payments (BoP, current US$) of New Caledonia in 2010 to that in 2013?
Make the answer very short. 0.91. What is the ratio of the Payments (BoP, current US$) of Sub-Saharan Africa (all income levels) in 2011 to that in 2012?
Make the answer very short. 0.98. What is the ratio of the Payments (BoP, current US$) of Fiji in 2011 to that in 2012?
Your answer should be very brief. 0.96. What is the ratio of the Payments (BoP, current US$) of Mongolia in 2011 to that in 2012?
Your answer should be very brief. 0.94. What is the ratio of the Payments (BoP, current US$) of New Caledonia in 2011 to that in 2012?
Keep it short and to the point. 1.01. What is the ratio of the Payments (BoP, current US$) in Sub-Saharan Africa (all income levels) in 2011 to that in 2013?
Make the answer very short. 0.95. What is the ratio of the Payments (BoP, current US$) in Fiji in 2011 to that in 2013?
Your response must be concise. 0.86. What is the ratio of the Payments (BoP, current US$) of Mongolia in 2011 to that in 2013?
Your response must be concise. 1.01. What is the ratio of the Payments (BoP, current US$) in New Caledonia in 2011 to that in 2013?
Make the answer very short. 1.02. What is the ratio of the Payments (BoP, current US$) in Sub-Saharan Africa (all income levels) in 2012 to that in 2013?
Your answer should be compact. 0.97. What is the ratio of the Payments (BoP, current US$) of Fiji in 2012 to that in 2013?
Keep it short and to the point. 0.89. What is the ratio of the Payments (BoP, current US$) of Mongolia in 2012 to that in 2013?
Your answer should be very brief. 1.08. What is the ratio of the Payments (BoP, current US$) of New Caledonia in 2012 to that in 2013?
Provide a short and direct response. 1.01. What is the difference between the highest and the second highest Payments (BoP, current US$) of Sub-Saharan Africa (all income levels)?
Your answer should be very brief. 1.84e+1. What is the difference between the highest and the second highest Payments (BoP, current US$) in Fiji?
Give a very brief answer. 3.31e+08. What is the difference between the highest and the second highest Payments (BoP, current US$) of Mongolia?
Keep it short and to the point. 5.24e+08. What is the difference between the highest and the second highest Payments (BoP, current US$) in New Caledonia?
Ensure brevity in your answer.  3.68e+07. What is the difference between the highest and the lowest Payments (BoP, current US$) in Sub-Saharan Africa (all income levels)?
Offer a very short reply. 1.97e+11. What is the difference between the highest and the lowest Payments (BoP, current US$) of Fiji?
Give a very brief answer. 1.32e+09. What is the difference between the highest and the lowest Payments (BoP, current US$) in Mongolia?
Your response must be concise. 6.15e+09. What is the difference between the highest and the lowest Payments (BoP, current US$) in New Caledonia?
Give a very brief answer. 1.51e+09. 